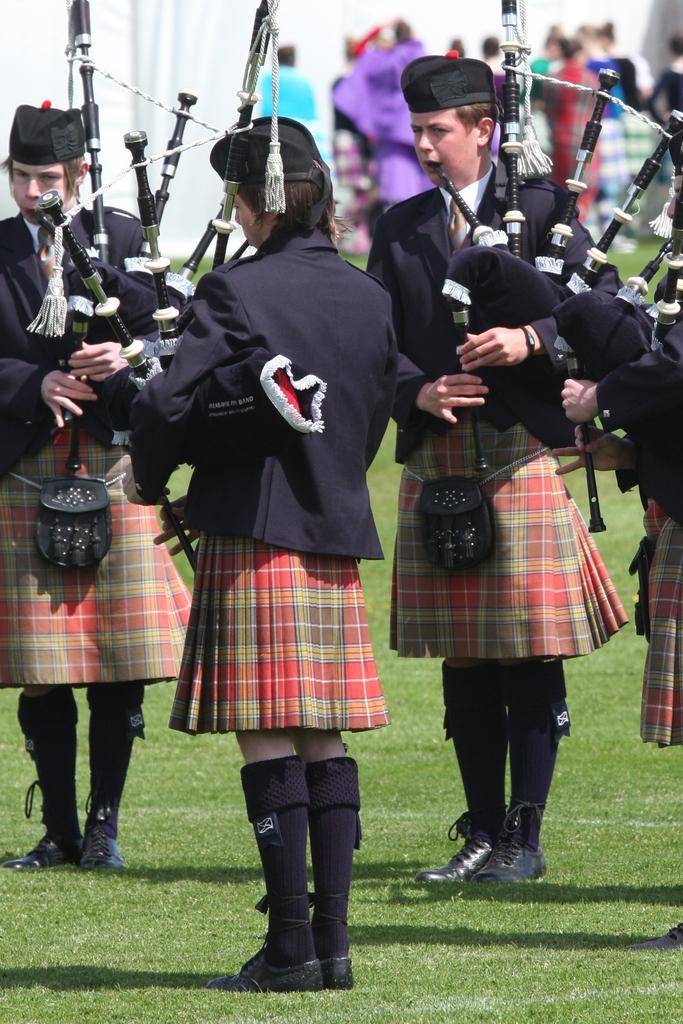How would you summarize this image in a sentence or two? In this image I can see few people wearing different costumes and holding something. Background is blurred. 